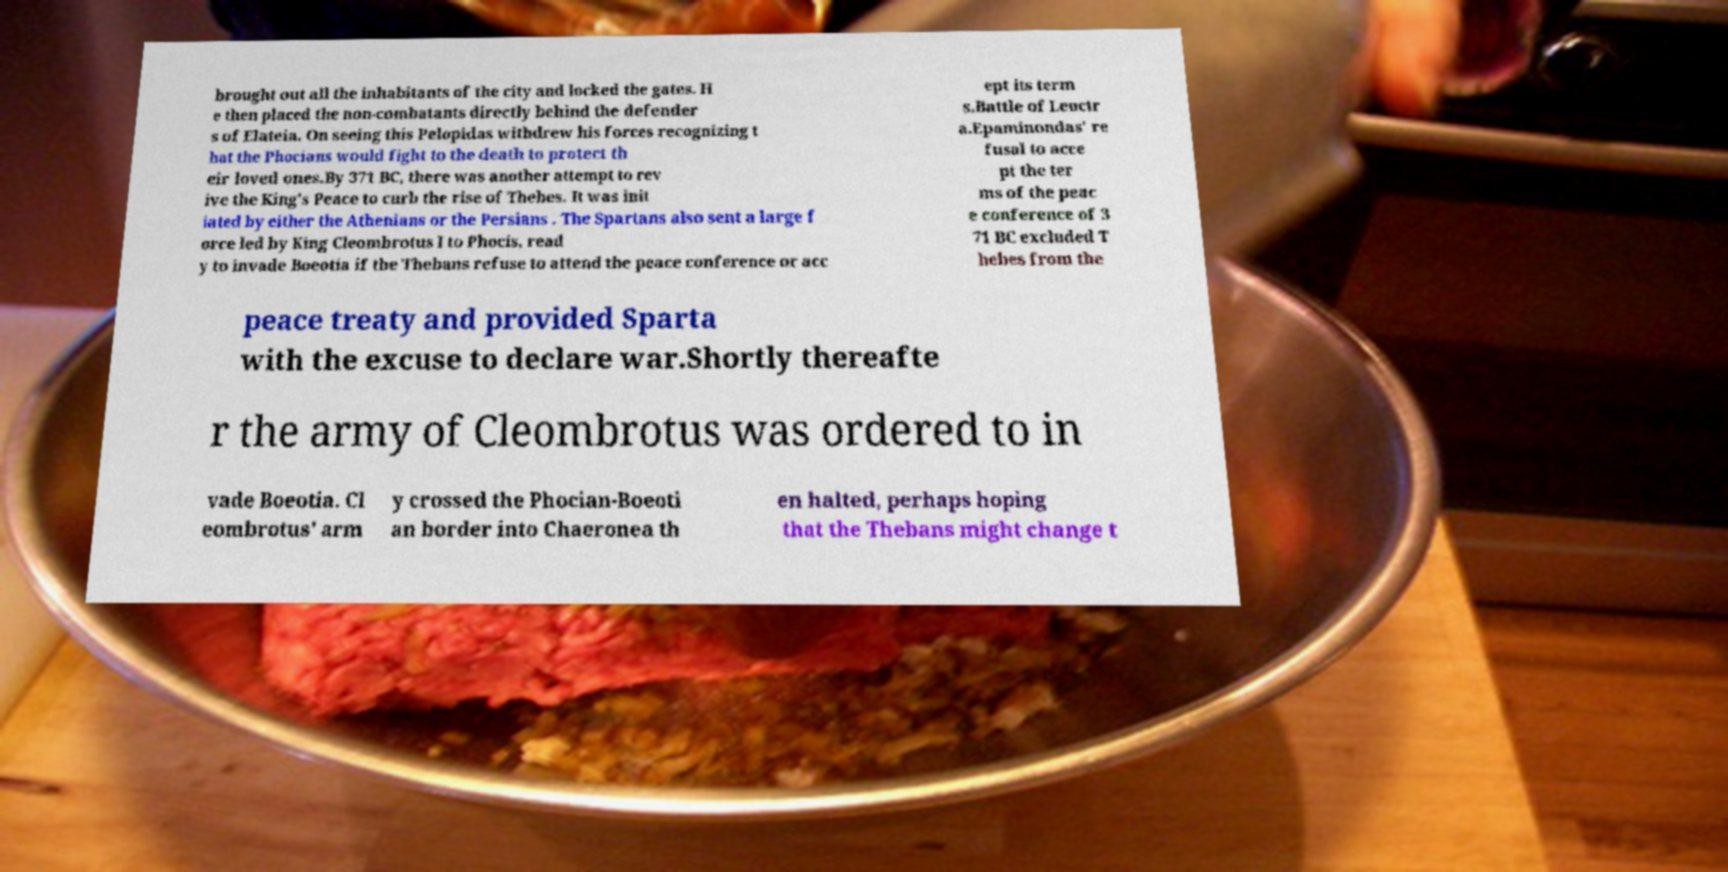I need the written content from this picture converted into text. Can you do that? brought out all the inhabitants of the city and locked the gates. H e then placed the non-combatants directly behind the defender s of Elateia. On seeing this Pelopidas withdrew his forces recognizing t hat the Phocians would fight to the death to protect th eir loved ones.By 371 BC, there was another attempt to rev ive the King's Peace to curb the rise of Thebes. It was init iated by either the Athenians or the Persians . The Spartans also sent a large f orce led by King Cleombrotus I to Phocis, read y to invade Boeotia if the Thebans refuse to attend the peace conference or acc ept its term s.Battle of Leuctr a.Epaminondas' re fusal to acce pt the ter ms of the peac e conference of 3 71 BC excluded T hebes from the peace treaty and provided Sparta with the excuse to declare war.Shortly thereafte r the army of Cleombrotus was ordered to in vade Boeotia. Cl eombrotus' arm y crossed the Phocian-Boeoti an border into Chaeronea th en halted, perhaps hoping that the Thebans might change t 